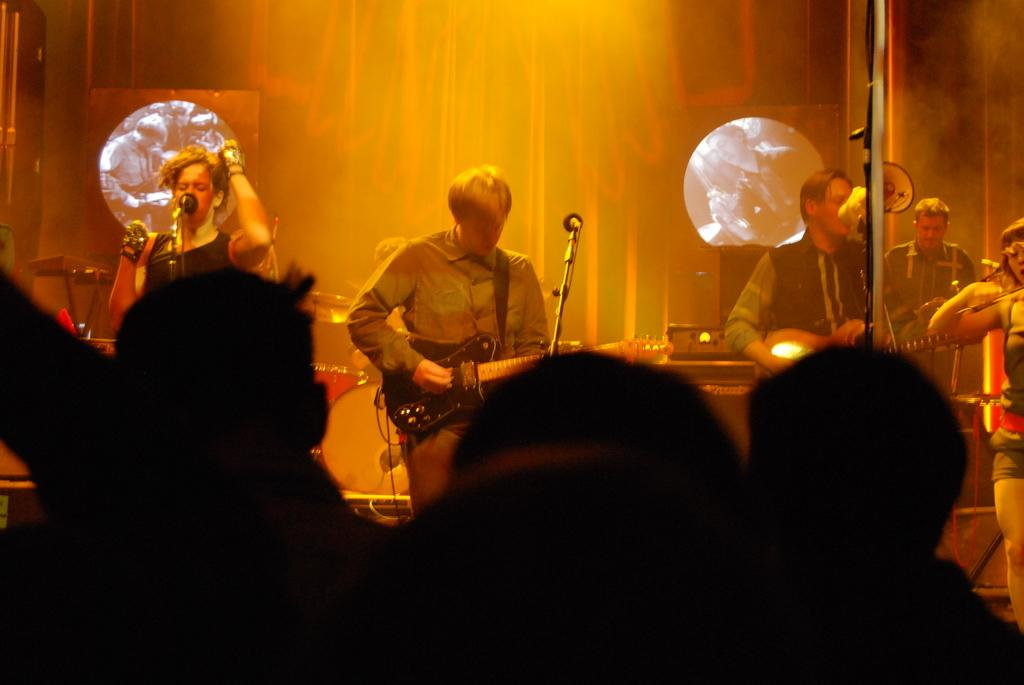How many people are performing in the image? There are two men in the image, and they are playing a guitar. What is the woman in the image doing? The woman is singing in the image. Who is the audience for the performance? There is a group of people in the image, and they are watching the performance. What type of friction can be seen between the guitar strings and the guitar in the image? There is no visible friction between the guitar strings and the guitar in the image. How many bedrooms are present in the image? There are no bedrooms present in the image. 